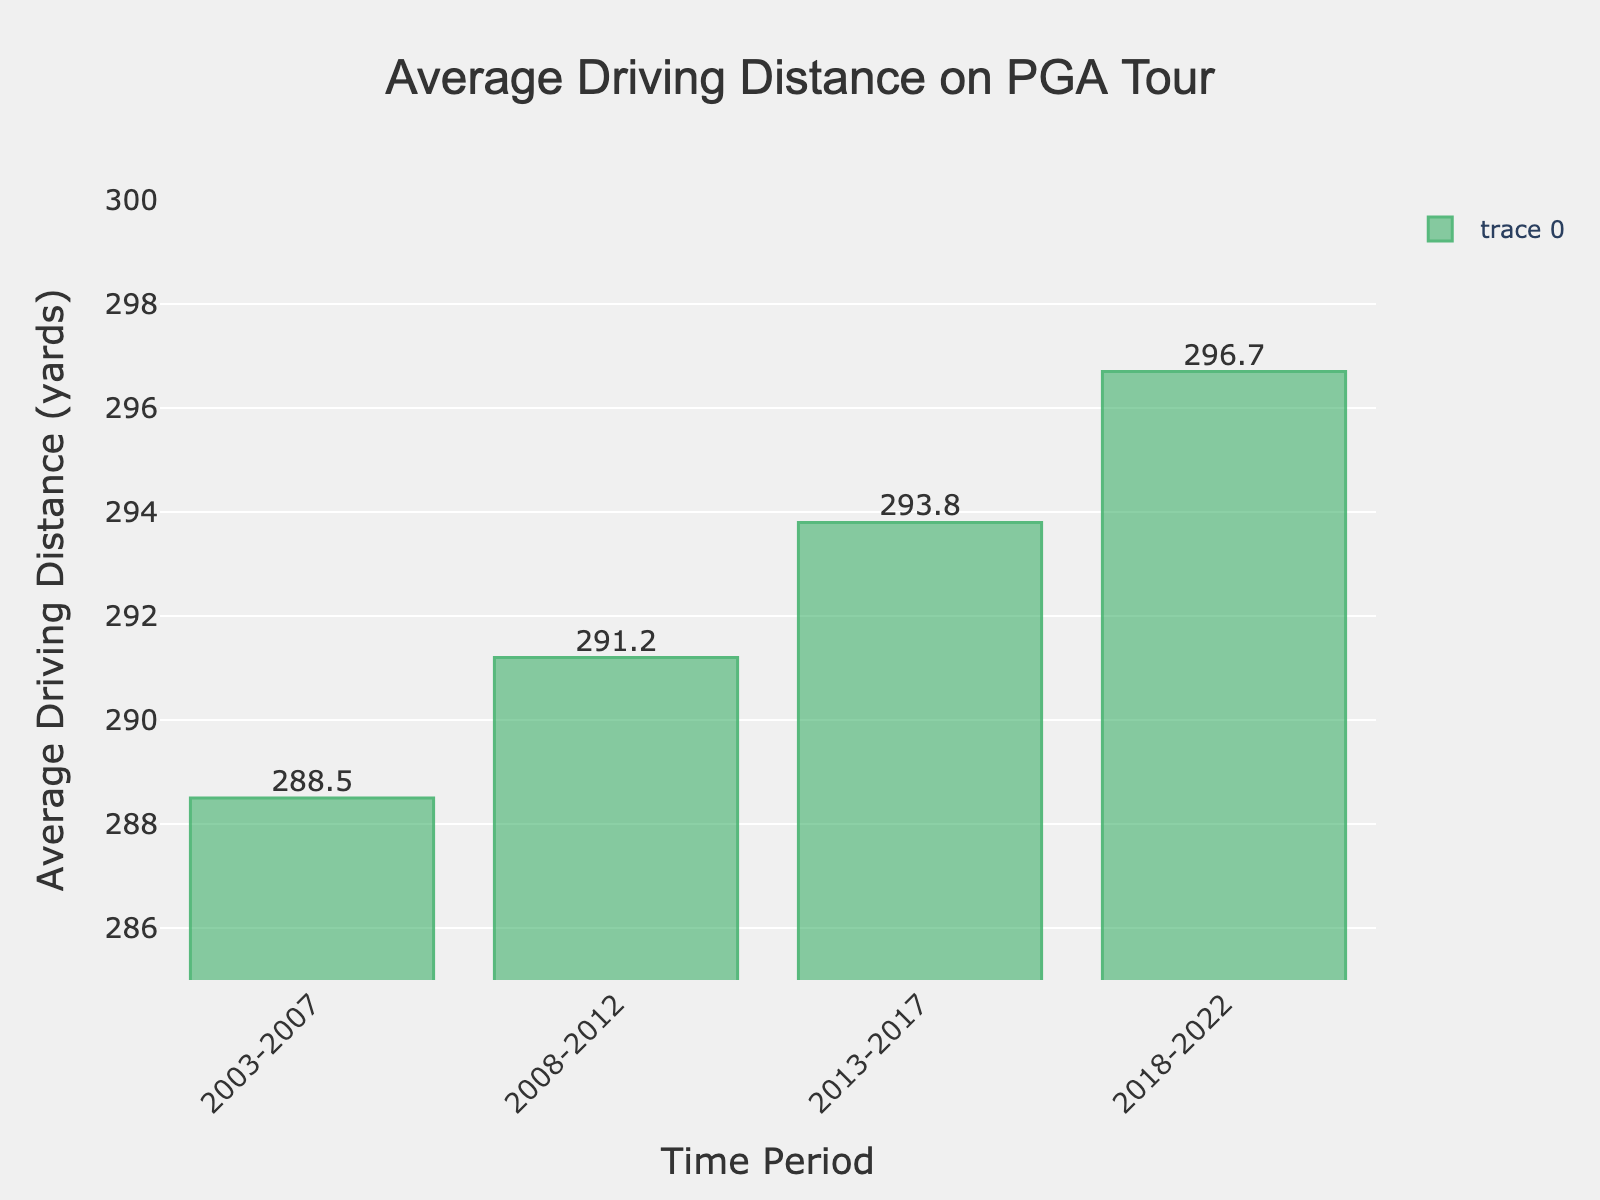What's the time period with the highest average driving distance? The tallest bar on the chart represents the highest average driving distance, which is from the years 2018-2022. The value indicated at the top of this period is 296.7 yards.
Answer: 2018-2022 What's the difference in average driving distance between the periods 2003-2007 and 2018-2022? Subtract the average driving distance of the period 2003-2007 (288.5 yards) from the average driving distance of the period 2018-2022 (296.7 yards). The difference is 296.7 - 288.5 = 8.2 yards.
Answer: 8.2 yards How has the average driving distance changed over the entire time span shown in the chart? The average driving distance has incrementally increased. Starting from 288.5 yards in the 2003-2007 period, it went up to 291.2 in 2008-2012, 293.8 in 2013-2017, and finally to 296.7 in 2018-2022. This demonstrates a consistent upward trend.
Answer: Increased Which time period has an average driving distance closest to 290 yards? The average driving distance for the period 2008-2012 is 291.2 yards, which is the closest to 290 yards among all periods represented.
Answer: 2008-2012 If you average the driving distances from 2003-2007 and 2013-2017, what result do you get? Add the average driving distances for the periods 2003-2007 (288.5 yards) and 2013-2017 (293.8 yards), and then divide by 2. The calculation is (288.5 + 293.8) / 2 = 582.3 / 2 = 291.15 yards.
Answer: 291.15 yards What is the range of average driving distances covered by this data? The range is determined by subtracting the smallest average driving distance (288.5 yards for 2003-2007) from the largest average driving distance (296.7 yards for 2018-2022). The calculation is 296.7 - 288.5 = 8.2 yards.
Answer: 8.2 yards When comparing 2008-2012 and 2013-2017, which period shows a greater increase in driving distance over the previous period? The increase from 2003-2007 to 2008-2012 is 291.2 - 288.5 = 2.7 yards, and from 2008-2012 to 2013-2017 it is 293.8 - 291.2 = 2.6 yards. The period 2008-2012 shows a slightly greater increase (2.7 yards) compared to the 2013-2017 period (2.6 yards).
Answer: 2008-2012 In which period do we see the smallest increase in average driving distance from the previous period? Calculate the increases between successive periods: 2003-2007 to 2008-2012 is 2.7 yards, 2008-2012 to 2013-2017 is 2.6 yards, and 2013-2017 to 2018-2022 is 2.9 yards. The smallest increase, 2.6 yards, occurs between 2008-2012 and 2013-2017.
Answer: 2013-2017 Rank the time periods from highest to lowest average driving distance. The values are 296.7 yards (2018-2022), 293.8 yards (2013-2017), 291.2 yards (2008-2012), and 288.5 yards (2003-2007). Ranking them from highest to lowest: 2018-2022, 2013-2017, 2008-2012, 2003-2007.
Answer: 2018-2022, 2013-2017, 2008-2012, 2003-2007 Is there any time period where the average driving distance is less than 290 yards? By looking at the chart, the only period with an average driving distance below 290 yards is 2003-2007, with an average driving distance of 288.5 yards.
Answer: 2003-2007 